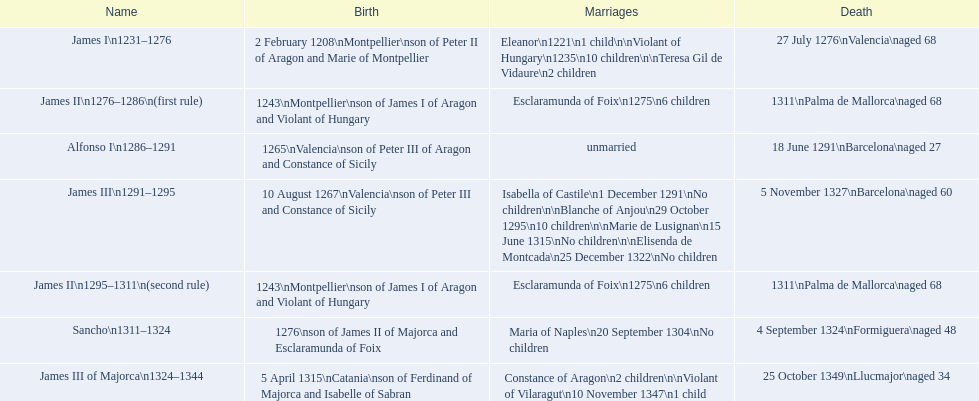How many among these sovereigns deceased prior to their 65th birthday? 4. 